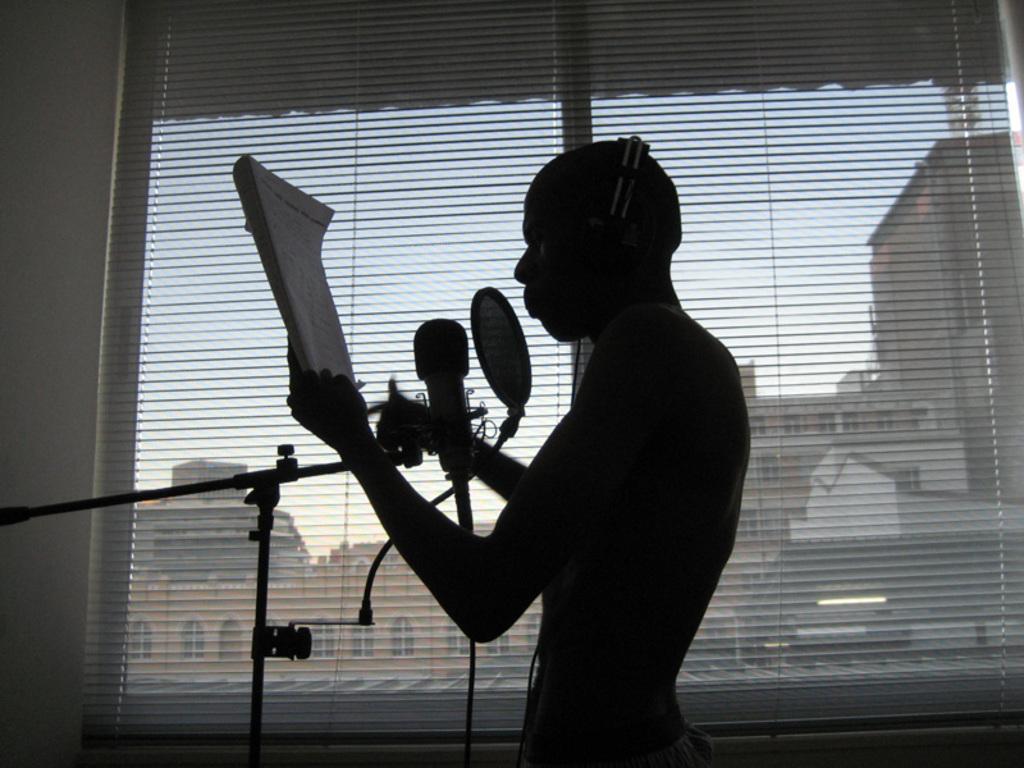Could you give a brief overview of what you see in this image? In this picture there is a person wearing headset and holding a book in his hand is singing in front of a mic and there is a glass window beside him and there are buildings in the background. 